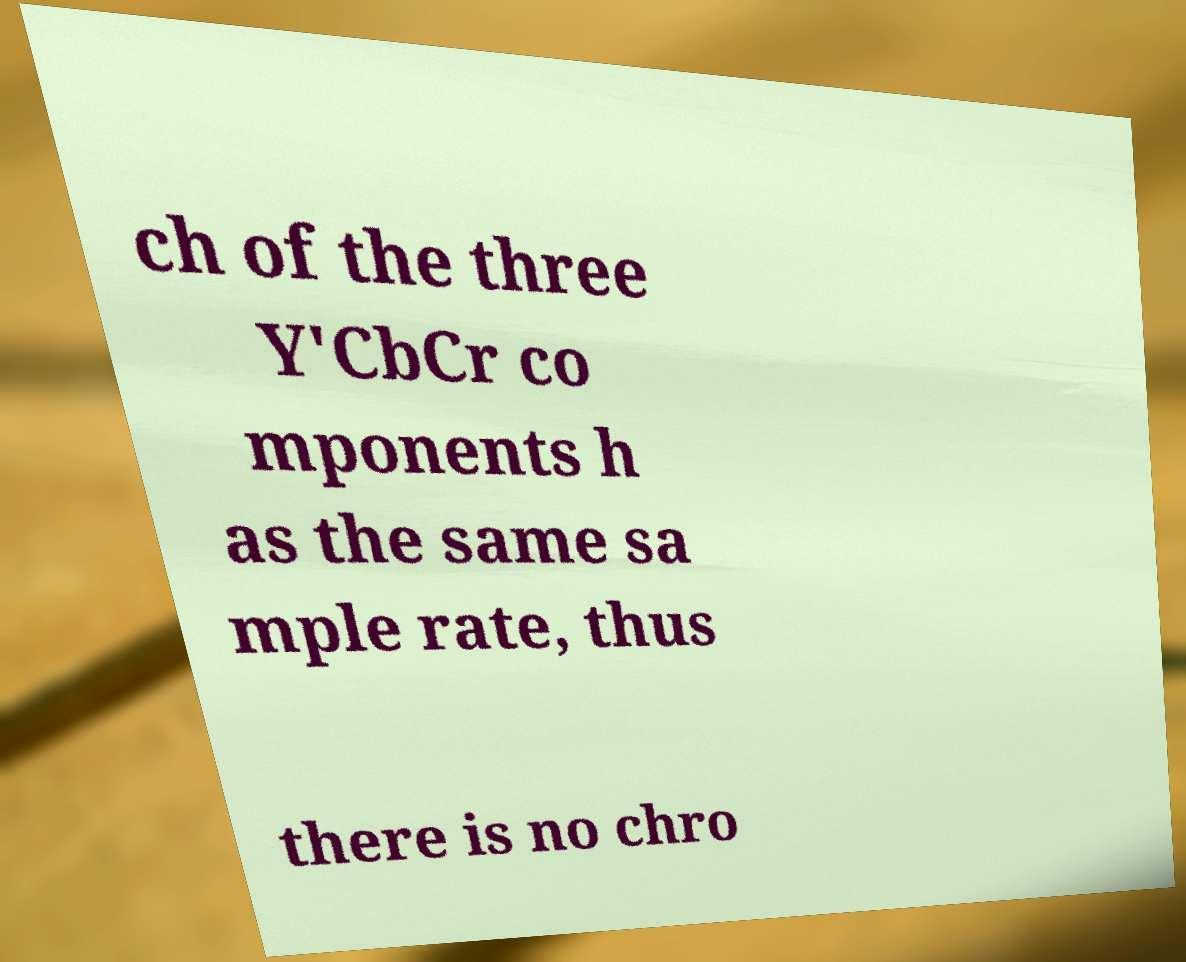There's text embedded in this image that I need extracted. Can you transcribe it verbatim? ch of the three Y'CbCr co mponents h as the same sa mple rate, thus there is no chro 